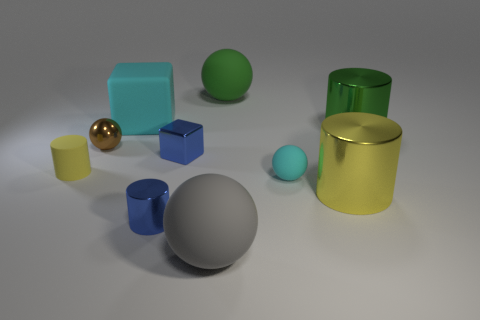Can you infer any real-world scale or size reference from the objects in the image? Without explicit real-world references or objects of known size, it's difficult to determine the exact scale or size. However, based on general object recognition, the items might resemble common household or office items like paperweights, containers, or decorative ornaments, which typically range from a few centimeters to tens of centimeters in size. 